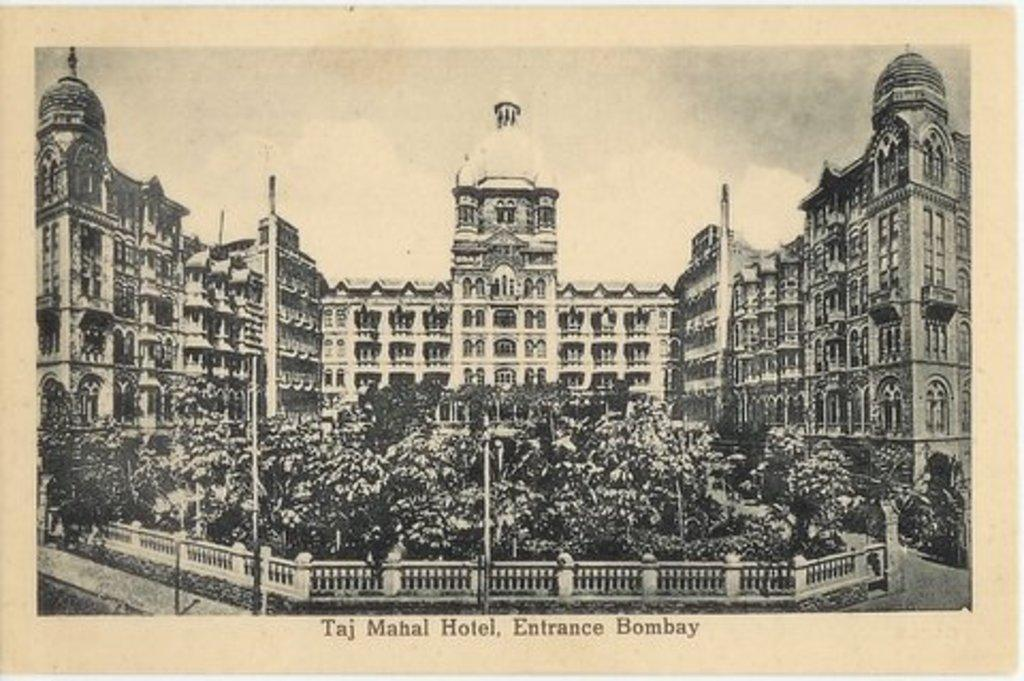Provide a one-sentence caption for the provided image. A black and white drawing of the Taj Mahal hotel. 